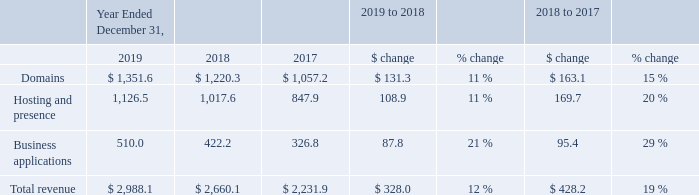Comparison of 2019 and 2018
Revenue
We generate substantially all of our revenue from sales of subscriptions, including domain registrations and renewals, hosting and presence products and business applications. Our subscription terms average one year, but can range from monthly terms to multi-annual terms of up to ten years depending on the product. We generally collect the full amount of subscription fees at the time of sale, while revenue is recognized over the period in which the performance obligations are satisfied, which is generally over the contract term. Revenue is presented net of refunds, and we maintain a reserve to provide for refunds granted to customers
Domains revenue primarily consists of revenue from the sale of domain registration subscriptions, domain add-ons and aftermarket domain sales. Domain registrations provide a customer with the exclusive use of a domain during the applicable contract term. After the contract term expires, unless renewed, the customer can no longer access the domain.
Hosting and presence revenue primarily consists of revenue from the sale of subscriptions for our website hosting products, website building products, website security products and online visibility products.
Business applications revenue primarily consists of revenue from the sale of subscriptions for third-party productivity applications, email accounts, email marketing tools and telephony solutions.
The following table presents our revenue for the periods indicated:
The 12.3% increase in total revenue was driven by growth in total customers and ARPU as well as having a full year of revenue from MSH in 2019, partially offset by the impact of movements in foreign currency exchange rates. The increase in customers impacted each of our revenue lines, as the additional customers purchased subscriptions across our product portfolio.
Domains. The 10.8% increase in domains revenue was primarily driven by the increase in domains under management from 77.6 million as of December 31, 2018 to 79.6 million as of December 31, 2019, increased aftermarket domain sales and international growth
Hosting and presence. The 10.7% increase in hosting and presence revenue was primarily driven by increased revenue from our website building and website security products as well as our acquisition of MSH.
Business applications. The 20.8% increase in business applications was primarily driven by increased customer adoption of our email, productivity and telephony solutions.
Which three types of revenues are listed in the table? Domains, hosting and presence, business applications. What is the domain revenue for each financial year in chronological order? $ 1,057.2, $ 1,220.3, $ 1,351.6. What is the hosting and presence revenue for each financial year in chronological order? 847.9, 1,017.6, 1,126.5. How many types of revenues are there? Domains ## Hosting and presence ## Business applications
Answer: 3. What is the average domain revenue for 2018 and 2019? (1,351.6+1,220.3)/2
Answer: 1285.95. What is the average hosting and presence revenue for 2018 and 2019? (1,126.5+1,017.6)/2
Answer: 1072.05. 